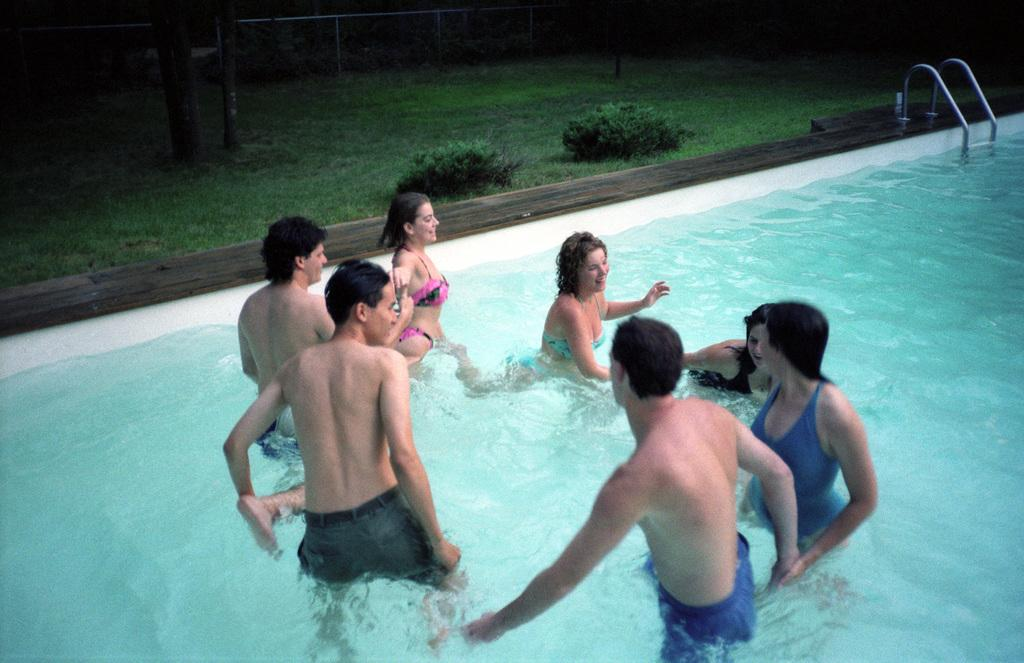What are the people in the image doing? There is a group of people in the water in the image. Where are the people in the water located? The water is in a swimming pool. What can be seen in the background of the image? There is grass, bushes, tree trunks, and a fence in the background of the image. What type of class is being taught in the image? There is no class or teaching activity present in the image; it features a group of people in a swimming pool. How many hands are visible in the image? It is not possible to determine the number of hands visible in the image, as the focus is on the people in the water and the surrounding environment. 